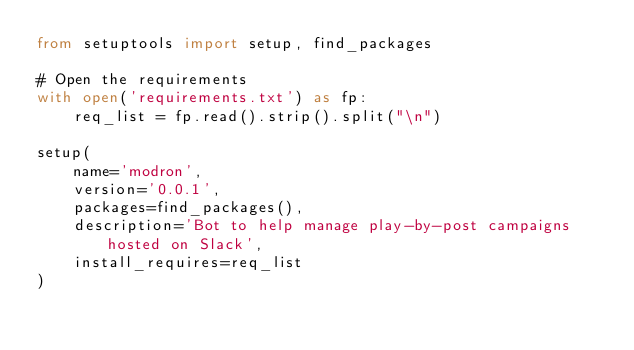<code> <loc_0><loc_0><loc_500><loc_500><_Python_>from setuptools import setup, find_packages

# Open the requirements
with open('requirements.txt') as fp:
    req_list = fp.read().strip().split("\n")

setup(
    name='modron',
    version='0.0.1',
    packages=find_packages(),
    description='Bot to help manage play-by-post campaigns hosted on Slack',
    install_requires=req_list
)
</code> 